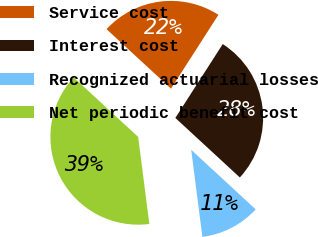Convert chart to OTSL. <chart><loc_0><loc_0><loc_500><loc_500><pie_chart><fcel>Service cost<fcel>Interest cost<fcel>Recognized actuarial losses<fcel>Net periodic benefit cost<nl><fcel>22.22%<fcel>27.78%<fcel>11.11%<fcel>38.89%<nl></chart> 